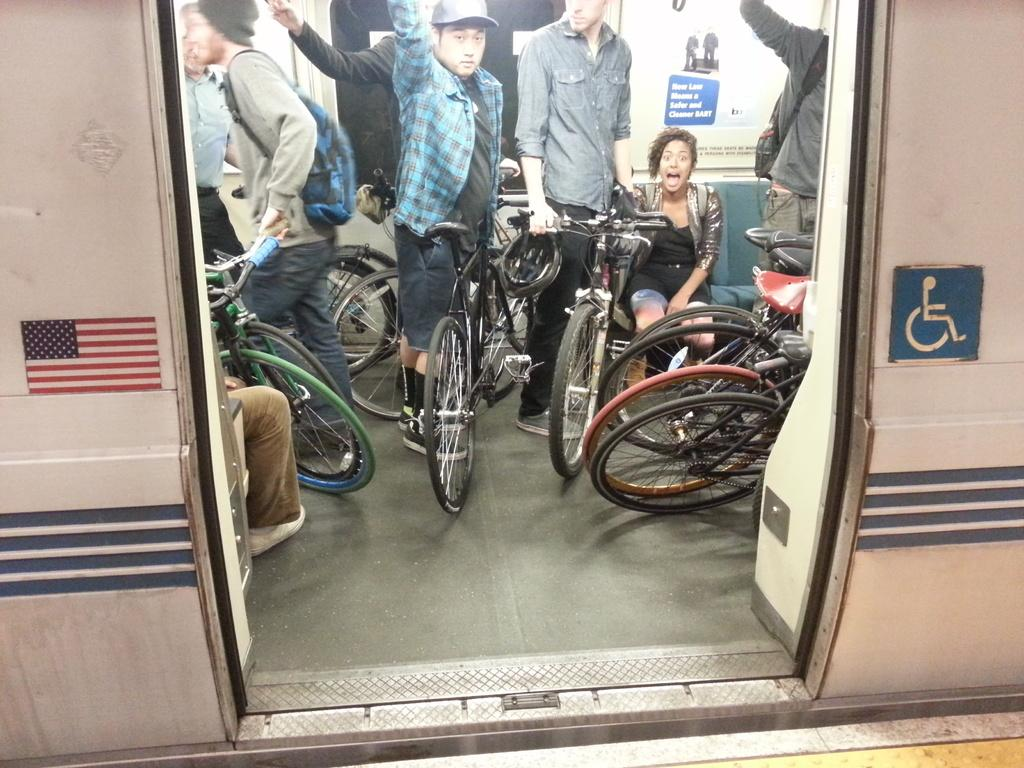Where was the image taken? The image was taken inside a train. What are the people in the image doing? The people in the image are standing with their bicycles in their hands. Can you describe the woman in the image? There is a woman sitting on a sofa at the right side of the image. What type of property does the woman own in the image? There is no information about the woman owning any property in the image. What time of day is it in the image? The provided facts do not mention the time of day, so it cannot be determined from the image. 